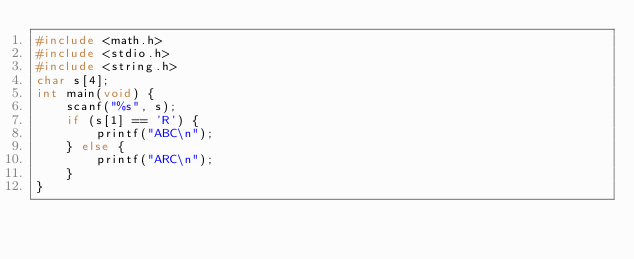Convert code to text. <code><loc_0><loc_0><loc_500><loc_500><_C_>#include <math.h>
#include <stdio.h>
#include <string.h>
char s[4];
int main(void) {
    scanf("%s", s);
    if (s[1] == 'R') {
        printf("ABC\n");
    } else {
        printf("ARC\n");
    }
}</code> 